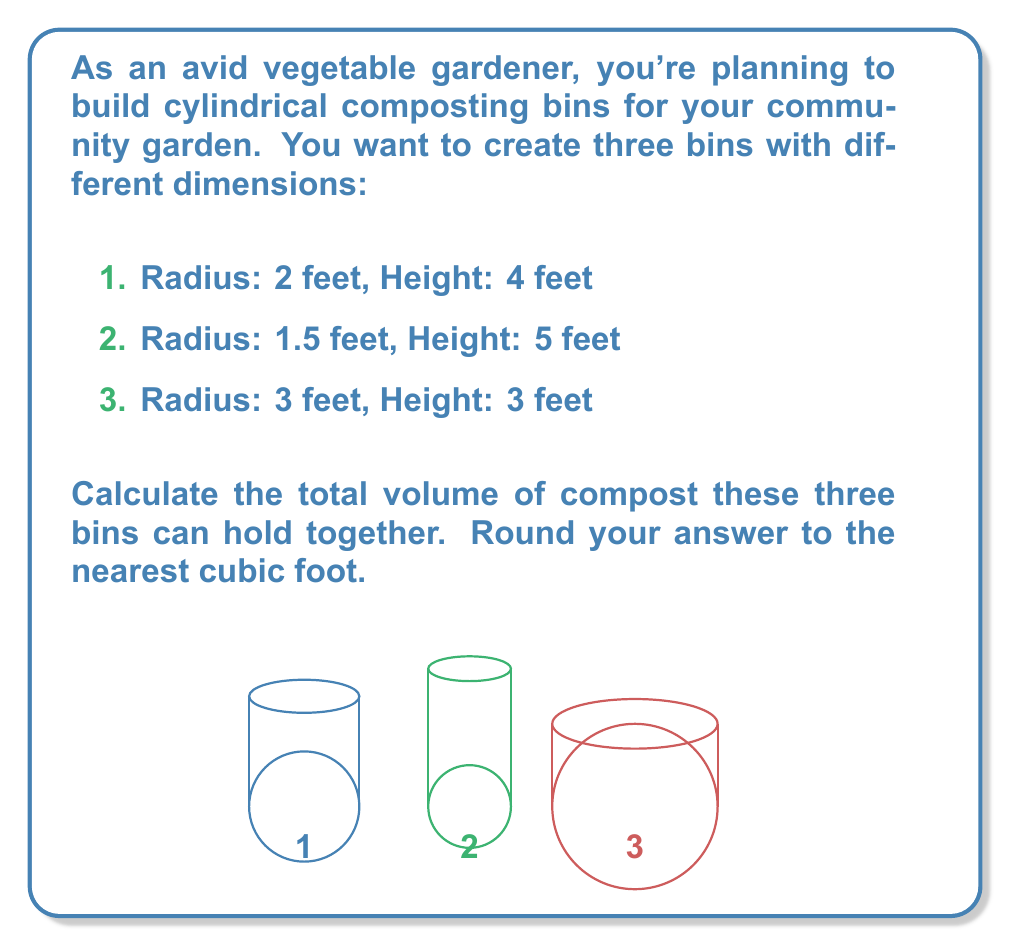Can you solve this math problem? To solve this problem, we need to calculate the volume of each cylindrical bin and then sum them up. The formula for the volume of a cylinder is:

$$V = \pi r^2 h$$

Where $V$ is volume, $r$ is radius, and $h$ is height.

Let's calculate the volume of each bin:

1. Bin 1: $r = 2$ feet, $h = 4$ feet
   $$V_1 = \pi (2^2) (4) = 16\pi \approx 50.27 \text{ cubic feet}$$

2. Bin 2: $r = 1.5$ feet, $h = 5$ feet
   $$V_2 = \pi (1.5^2) (5) = 11.25\pi \approx 35.34 \text{ cubic feet}$$

3. Bin 3: $r = 3$ feet, $h = 3$ feet
   $$V_3 = \pi (3^2) (3) = 27\pi \approx 84.82 \text{ cubic feet}$$

Now, let's sum up the volumes of all three bins:

$$V_{total} = V_1 + V_2 + V_3 \approx 50.27 + 35.34 + 84.82 = 170.43 \text{ cubic feet}$$

Rounding to the nearest cubic foot, we get 170 cubic feet.
Answer: 170 cubic feet 